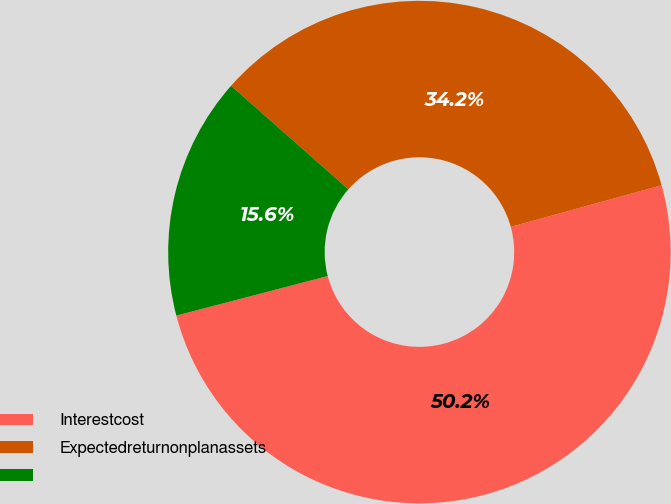Convert chart. <chart><loc_0><loc_0><loc_500><loc_500><pie_chart><fcel>Interestcost<fcel>Expectedreturnonplanassets<fcel>Unnamed: 2<nl><fcel>50.22%<fcel>34.2%<fcel>15.58%<nl></chart> 